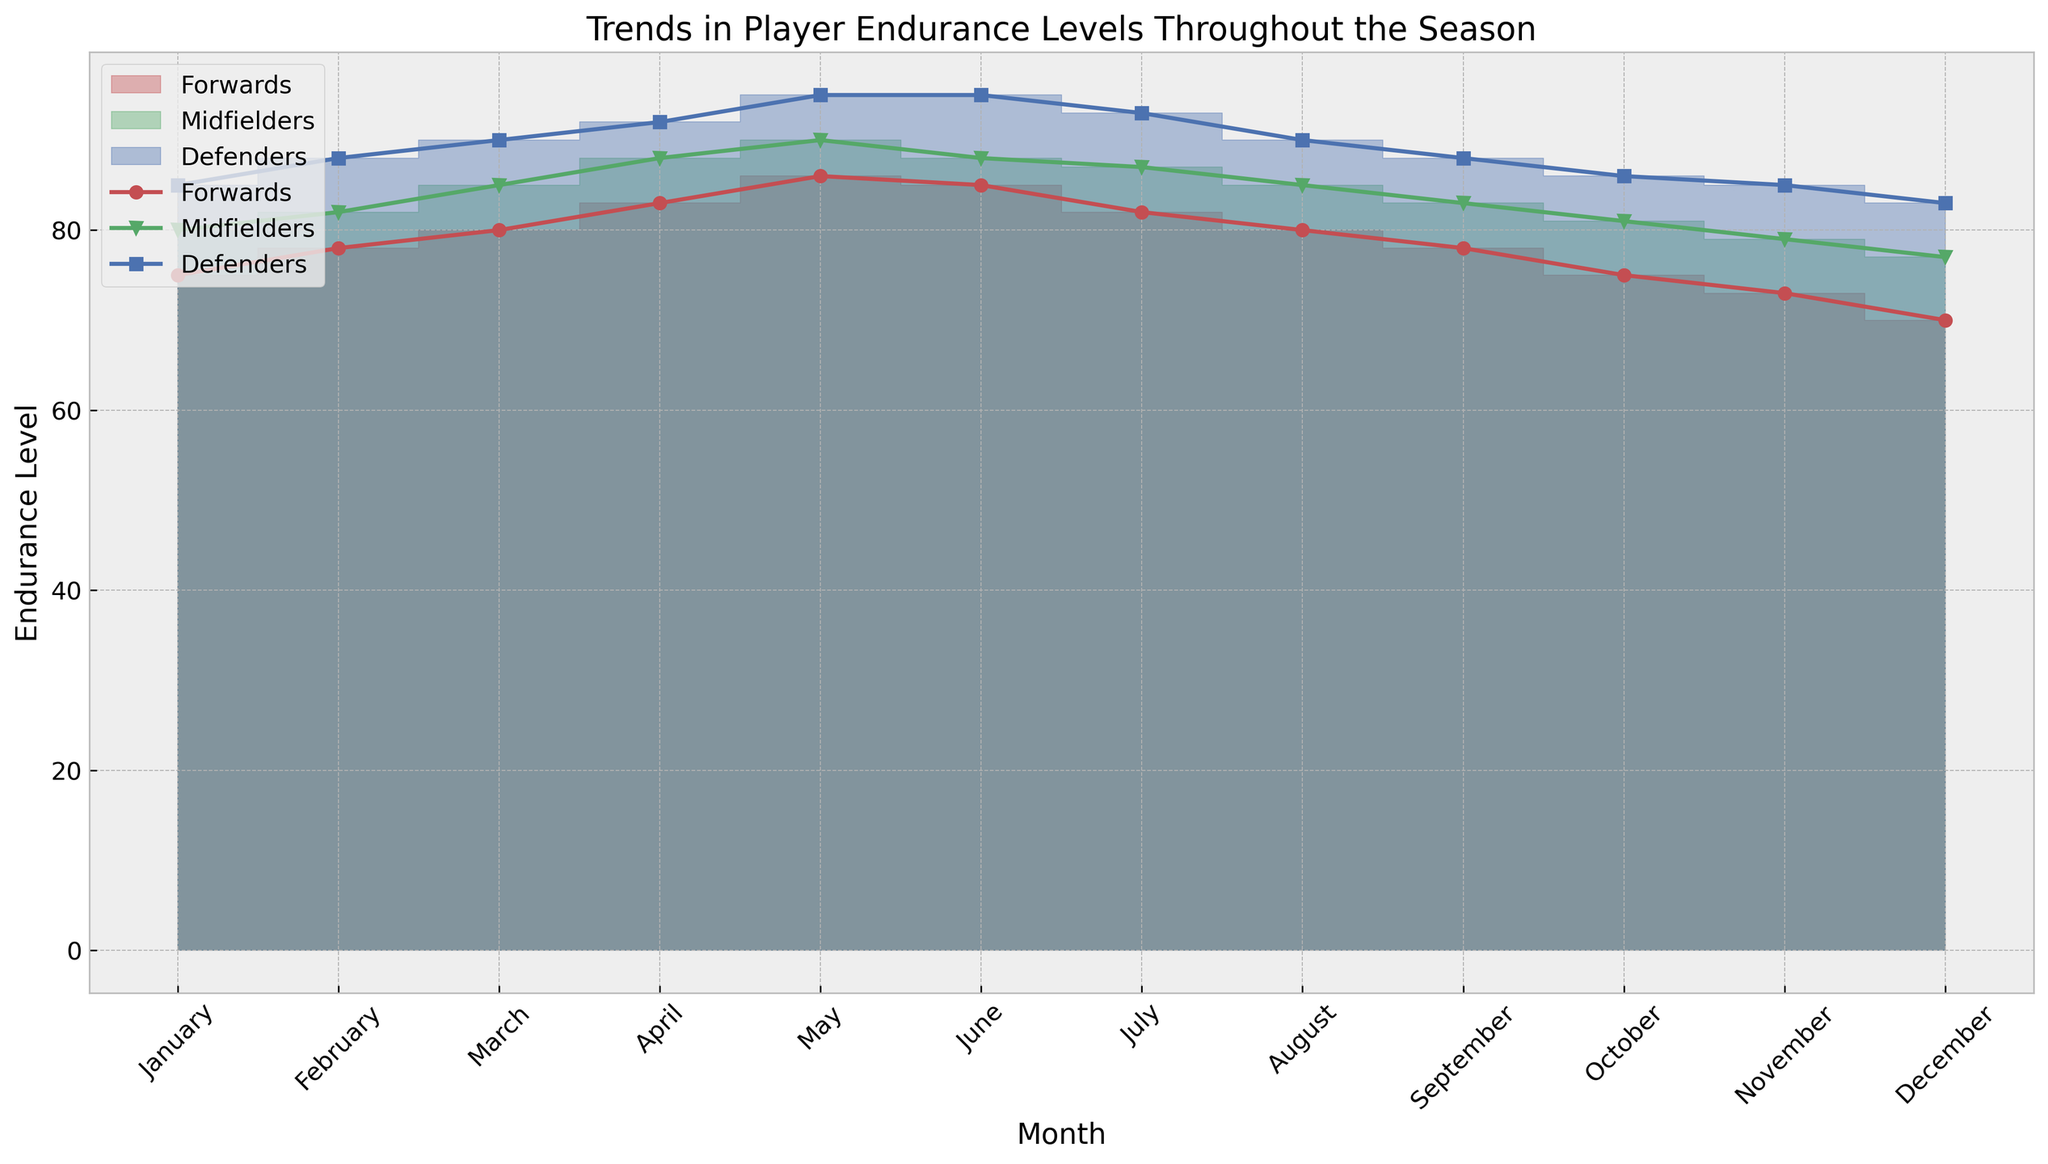Which month shows the highest endurance for forwards? In the figure, the endurance level for forwards peaks at the month labeled "May" where it's shown visibly at its highest point.
Answer: May Which group has the highest endurance level in June? Comparing the different positions in June, defenders have the highest endurance level at 95, followed by midfielders at 88, and forwards at 85.
Answer: Defenders How does the endurance level of midfielders change from January to December? Start with the midfielders' endurance level in January (80) and track the trend across the months to December (77), noting the peaks and valleys for a complete picture. It increases to May and plateaus before gradually decreasing again.
Answer: Decreases How do the endurance levels of defenders in January compare to those in December? The endurance level of defenders in January is 85, while in December it is 83. Therefore, the endurance level slightly decreases by 2 units.
Answer: Decrease by 2 What's the combined endurance level for all positions in March? Add the endurance values for forwards (80), midfielders (85), and defenders (90) in March: 80 + 85 + 90 = 255.
Answer: 255 Which position shows the most consistent endurance throughout the year? By looking at the common variations in the endurance levels over each month, defenders appear to have a smoother and more consistent curve as compared to the forwards and midfielders.
Answer: Defenders What is the difference in endurance levels between forwards and midfielders in July? The endurance level for forwards in July is 82, and for midfielders, it is 87. Subtract the endurance of forwards from midfielders: 87 - 82 = 5.
Answer: 5 Between summer months (June, July, August), which position has the lowest endurance? In the summer months, examine all the values for endurance levels and find the minimum value among all. For forwards, it's 80.
Answer: Forwards By how much does the endurance level of midfielders peak from the start to their highest point in the year? The endurance level of midfielders starts at 80 in January and peaks at 90 in May, a difference of 90 - 80 = 10.
Answer: 10 